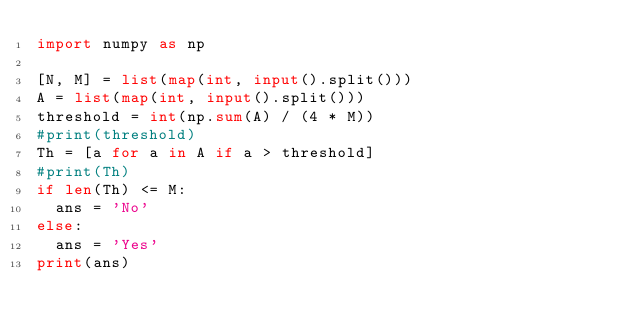<code> <loc_0><loc_0><loc_500><loc_500><_Python_>import numpy as np

[N, M] = list(map(int, input().split()))
A = list(map(int, input().split()))
threshold = int(np.sum(A) / (4 * M))
#print(threshold)
Th = [a for a in A if a > threshold]
#print(Th)
if len(Th) <= M:
  ans = 'No'
else:
  ans = 'Yes'
print(ans)</code> 